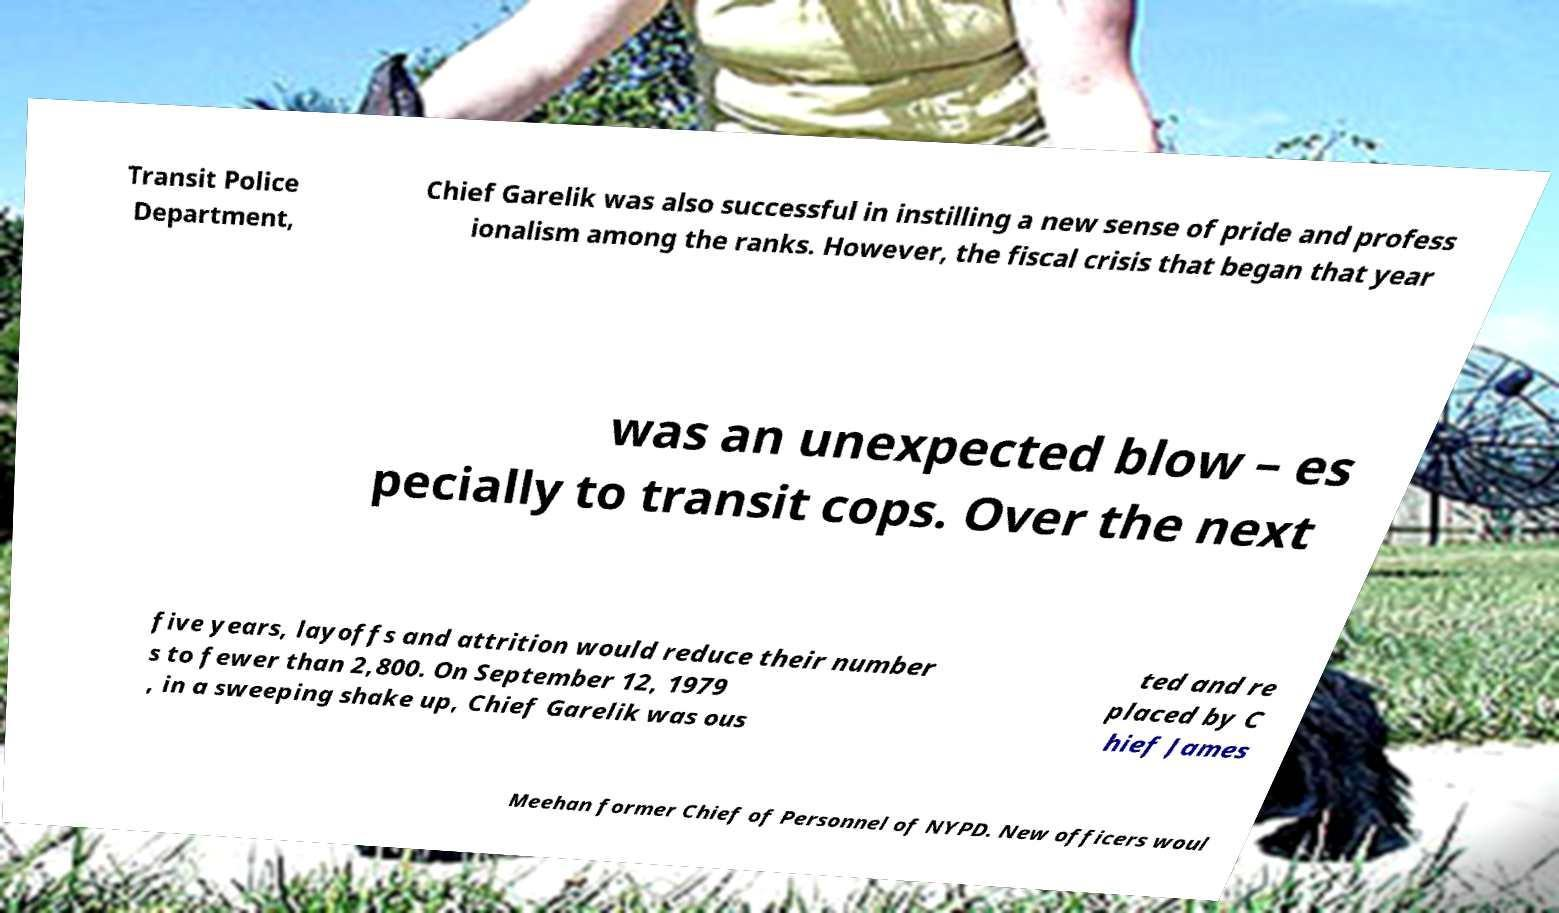Could you extract and type out the text from this image? Transit Police Department, Chief Garelik was also successful in instilling a new sense of pride and profess ionalism among the ranks. However, the fiscal crisis that began that year was an unexpected blow – es pecially to transit cops. Over the next five years, layoffs and attrition would reduce their number s to fewer than 2,800. On September 12, 1979 , in a sweeping shake up, Chief Garelik was ous ted and re placed by C hief James Meehan former Chief of Personnel of NYPD. New officers woul 